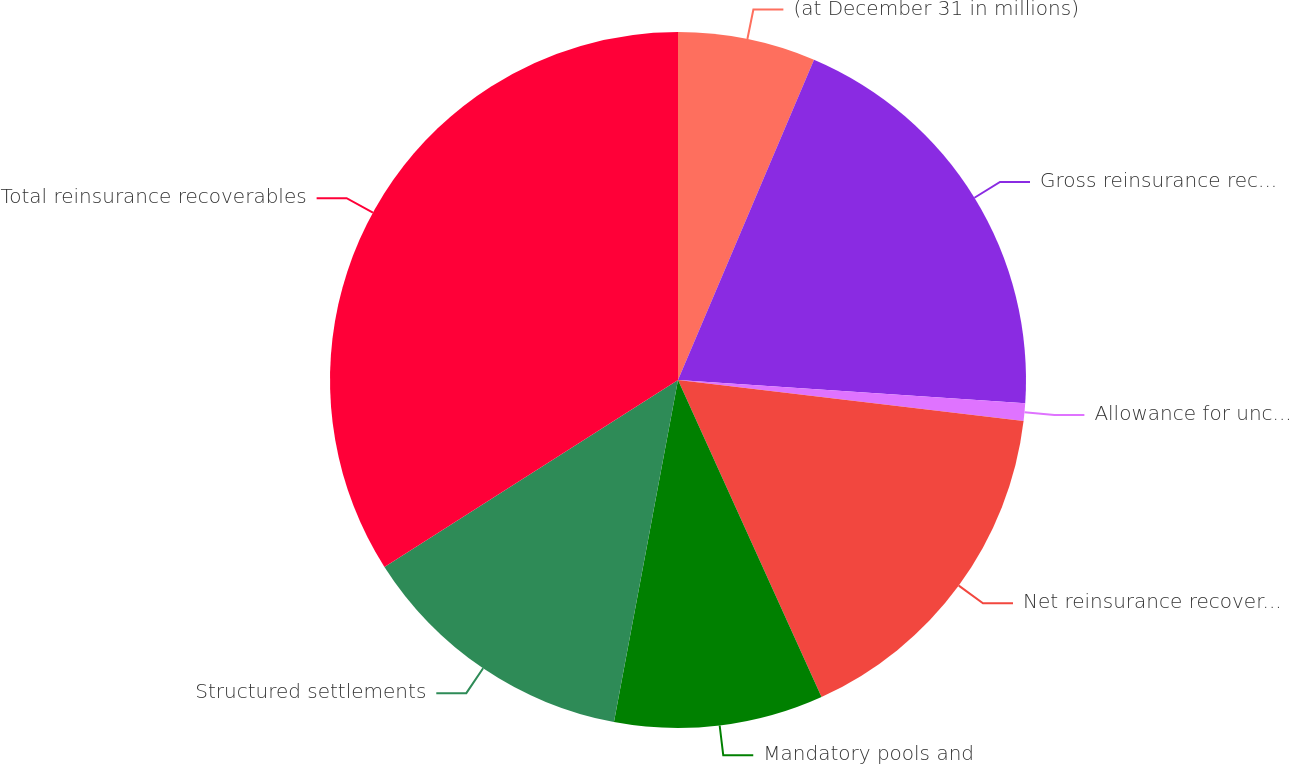Convert chart. <chart><loc_0><loc_0><loc_500><loc_500><pie_chart><fcel>(at December 31 in millions)<fcel>Gross reinsurance recoverables<fcel>Allowance for uncollectible<fcel>Net reinsurance recoverables<fcel>Mandatory pools and<fcel>Structured settlements<fcel>Total reinsurance recoverables<nl><fcel>6.39%<fcel>19.67%<fcel>0.82%<fcel>16.35%<fcel>9.71%<fcel>13.03%<fcel>34.02%<nl></chart> 